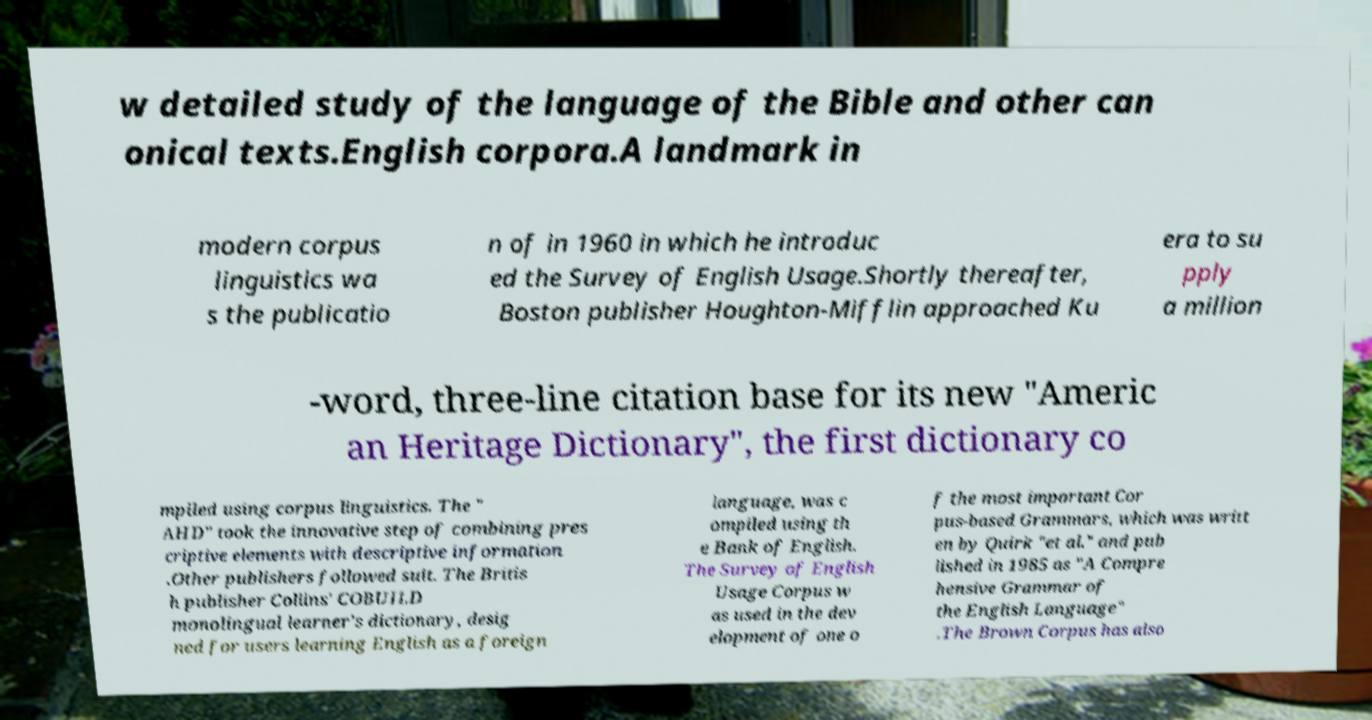Could you assist in decoding the text presented in this image and type it out clearly? w detailed study of the language of the Bible and other can onical texts.English corpora.A landmark in modern corpus linguistics wa s the publicatio n of in 1960 in which he introduc ed the Survey of English Usage.Shortly thereafter, Boston publisher Houghton-Mifflin approached Ku era to su pply a million -word, three-line citation base for its new "Americ an Heritage Dictionary", the first dictionary co mpiled using corpus linguistics. The " AHD" took the innovative step of combining pres criptive elements with descriptive information .Other publishers followed suit. The Britis h publisher Collins' COBUILD monolingual learner's dictionary, desig ned for users learning English as a foreign language, was c ompiled using th e Bank of English. The Survey of English Usage Corpus w as used in the dev elopment of one o f the most important Cor pus-based Grammars, which was writt en by Quirk "et al." and pub lished in 1985 as "A Compre hensive Grammar of the English Language" .The Brown Corpus has also 